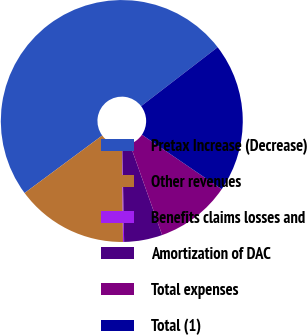Convert chart. <chart><loc_0><loc_0><loc_500><loc_500><pie_chart><fcel>Pretax Increase (Decrease)<fcel>Other revenues<fcel>Benefits claims losses and<fcel>Amortization of DAC<fcel>Total expenses<fcel>Total (1)<nl><fcel>49.7%<fcel>15.01%<fcel>0.15%<fcel>5.1%<fcel>10.06%<fcel>19.97%<nl></chart> 